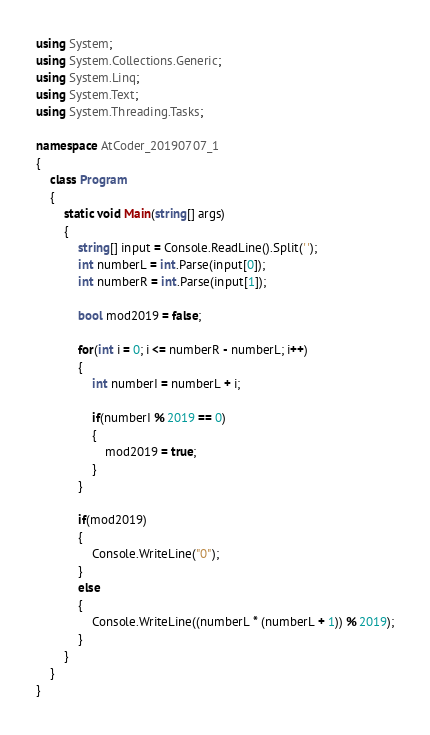<code> <loc_0><loc_0><loc_500><loc_500><_C#_>using System;
using System.Collections.Generic;
using System.Linq;
using System.Text;
using System.Threading.Tasks;

namespace AtCoder_20190707_1
{
    class Program
    {
        static void Main(string[] args)
        {
            string[] input = Console.ReadLine().Split(' ');
            int numberL = int.Parse(input[0]);
            int numberR = int.Parse(input[1]);

            bool mod2019 = false;

            for(int i = 0; i <= numberR - numberL; i++)
            {
                int numberI = numberL + i;

                if(numberI % 2019 == 0)
                {
                    mod2019 = true;
                }
            }

            if(mod2019)
            {
                Console.WriteLine("0");
            }
            else
            {
                Console.WriteLine((numberL * (numberL + 1)) % 2019);
            }            
        }
    }
}</code> 